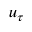<formula> <loc_0><loc_0><loc_500><loc_500>u _ { \tau }</formula> 